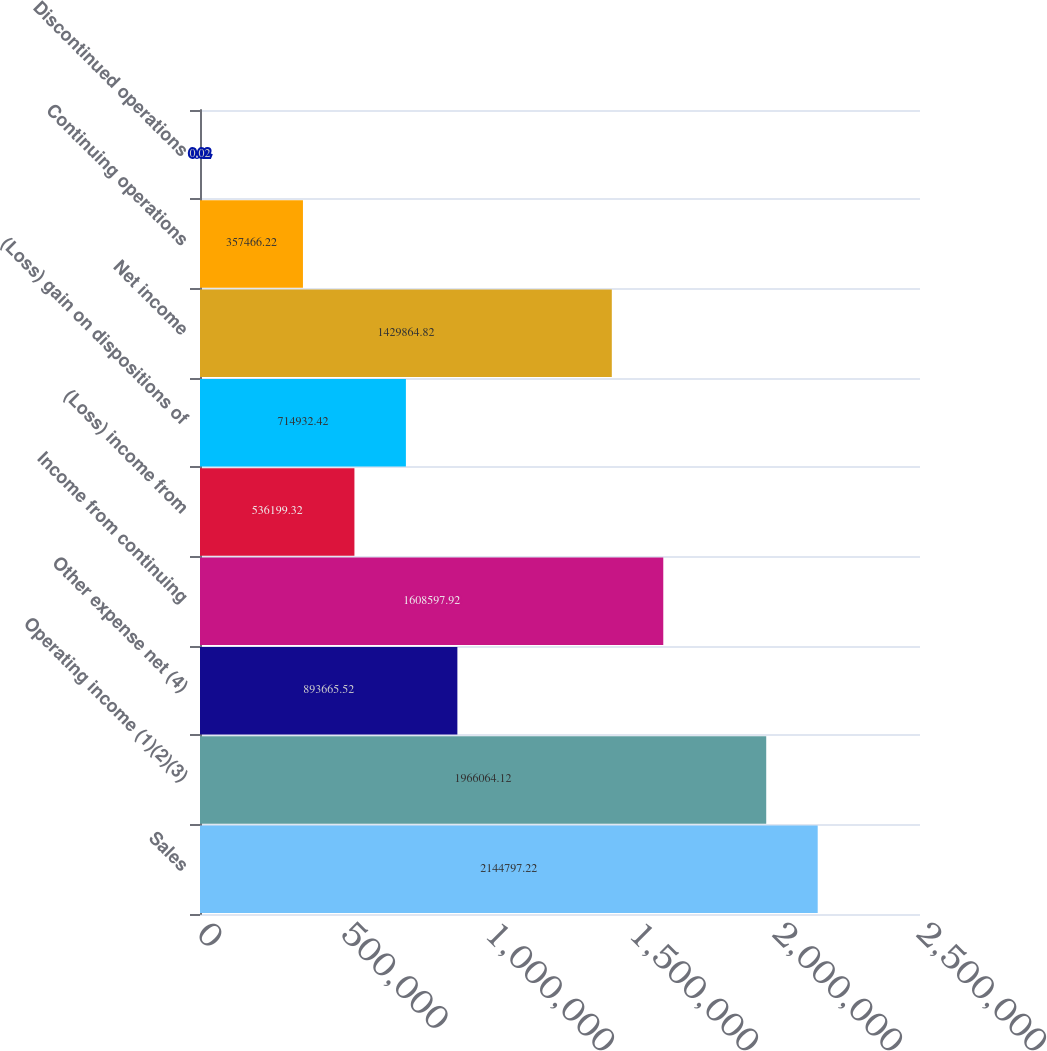Convert chart. <chart><loc_0><loc_0><loc_500><loc_500><bar_chart><fcel>Sales<fcel>Operating income (1)(2)(3)<fcel>Other expense net (4)<fcel>Income from continuing<fcel>(Loss) income from<fcel>(Loss) gain on dispositions of<fcel>Net income<fcel>Continuing operations<fcel>Discontinued operations<nl><fcel>2.1448e+06<fcel>1.96606e+06<fcel>893666<fcel>1.6086e+06<fcel>536199<fcel>714932<fcel>1.42986e+06<fcel>357466<fcel>0.02<nl></chart> 